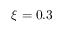Convert formula to latex. <formula><loc_0><loc_0><loc_500><loc_500>\xi = 0 . 3</formula> 